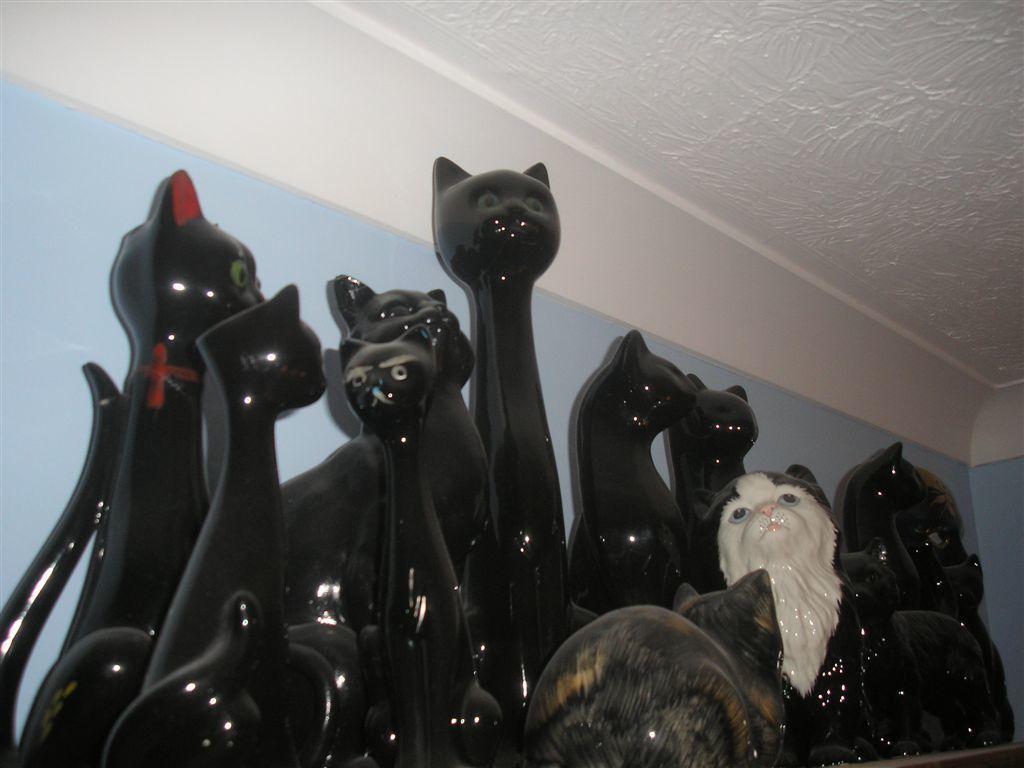Can you describe this image briefly? In the picture we can see a sculptured cats which are placed in the groups which are black in color, in the background we can see a wall and to the ceiling there is white in color. 